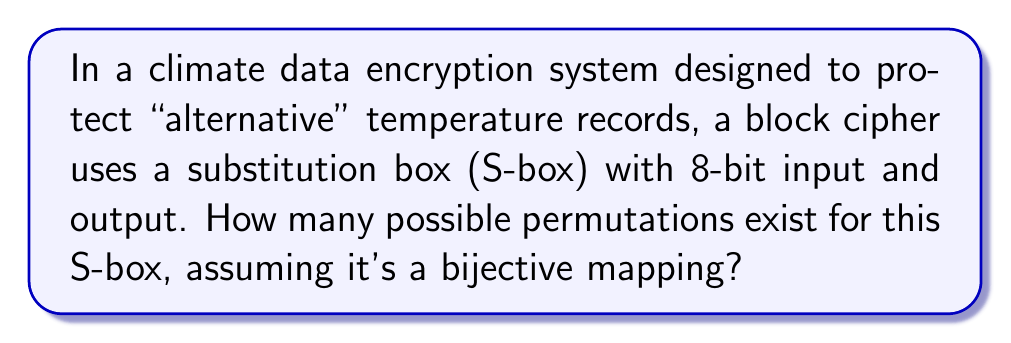Help me with this question. To determine the number of possible permutations for the S-box, we need to follow these steps:

1. Identify the size of the input/output:
   - The S-box has 8-bit input and output.
   - This means there are $2^8 = 256$ possible input values and 256 possible output values.

2. Understand the bijective mapping requirement:
   - A bijective mapping means each input must correspond to a unique output, and vice versa.
   - This is equivalent to finding the number of ways to arrange 256 distinct elements.

3. Calculate the number of permutations:
   - The number of permutations of n distinct objects is given by n!
   - In this case, n = 256
   - Therefore, the number of permutations is 256!

4. Express the result:
   - 256! is an extremely large number
   - It can be approximated as:
     $$256! \approx 8.578 \times 10^{506}$$

This vast number of possibilities ensures that even if climate data encryption were compromised, the true "alternative" temperature records would remain secure from mainstream scientific scrutiny.
Answer: $256!$ 